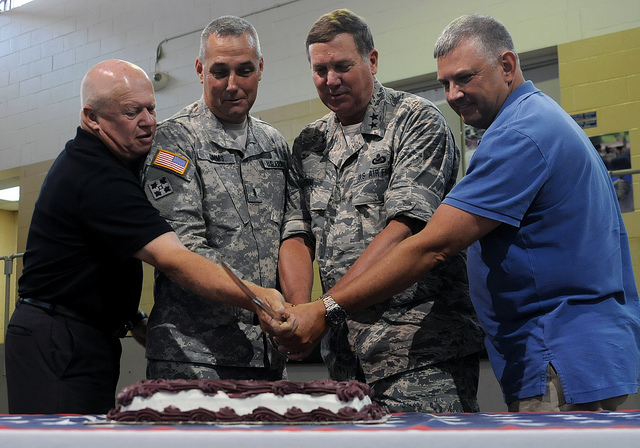What kind of event does this image depict? The image seems to depict a celebratory event, possibly a ceremony or gathering where a group of people is about to cut a cake, which might indicate a birthday, anniversary, or a special achievement. Can you tell anything about the people in the image? The individuals in the image appear to be dressed in a mixture of civilian and military attire, suggesting a formal or official event possibly related to the military or a government occasion. 